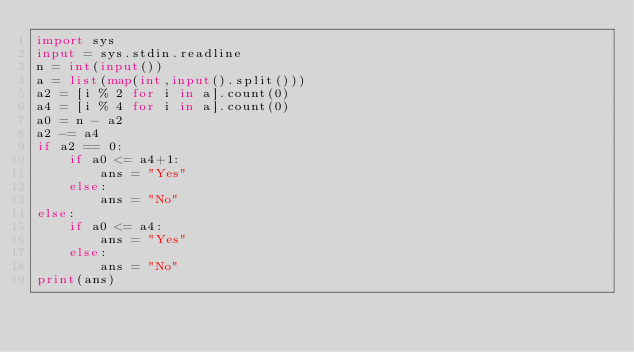Convert code to text. <code><loc_0><loc_0><loc_500><loc_500><_Python_>import sys
input = sys.stdin.readline
n = int(input())
a = list(map(int,input().split()))
a2 = [i % 2 for i in a].count(0)
a4 = [i % 4 for i in a].count(0)
a0 = n - a2
a2 -= a4
if a2 == 0:
    if a0 <= a4+1:
        ans = "Yes"
    else:
        ans = "No"
else:
    if a0 <= a4:
        ans = "Yes"
    else:
        ans = "No"
print(ans)
</code> 